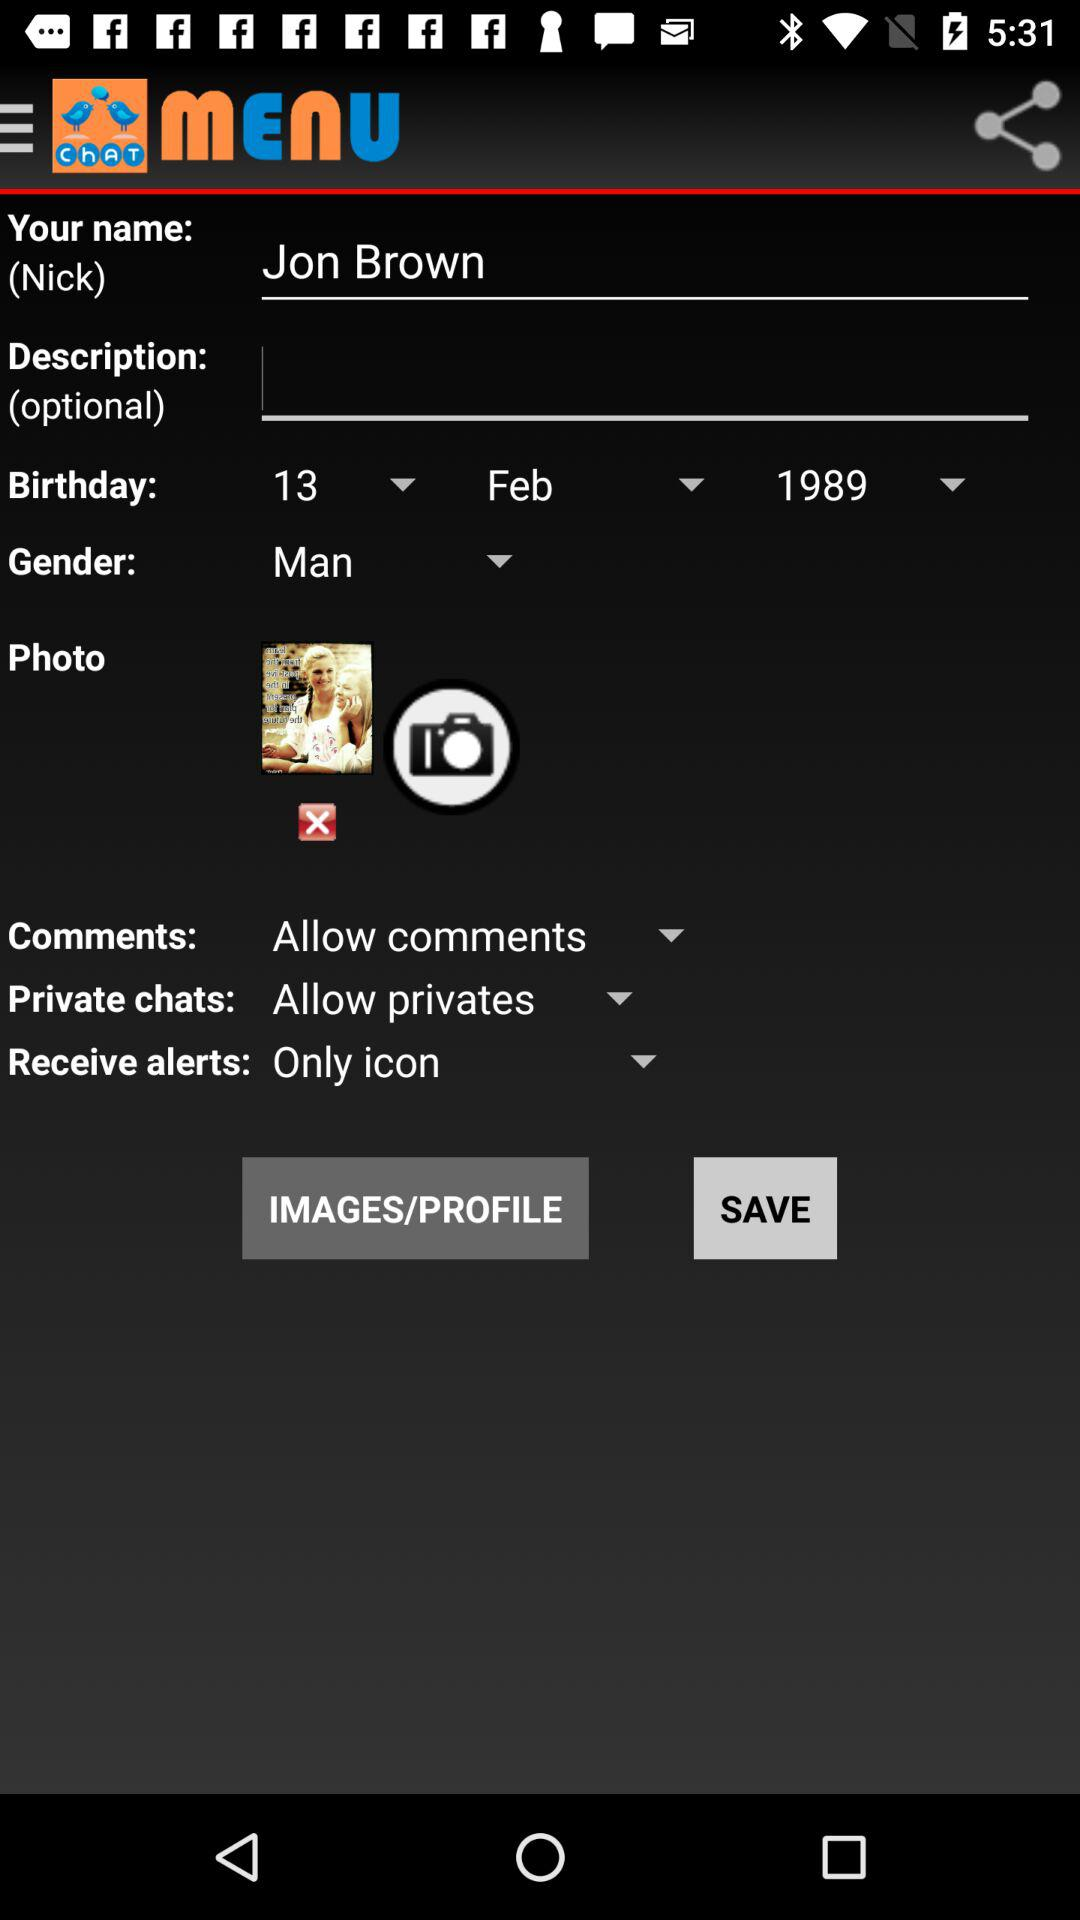What is the nickname? The nickname is Jon Brown. 